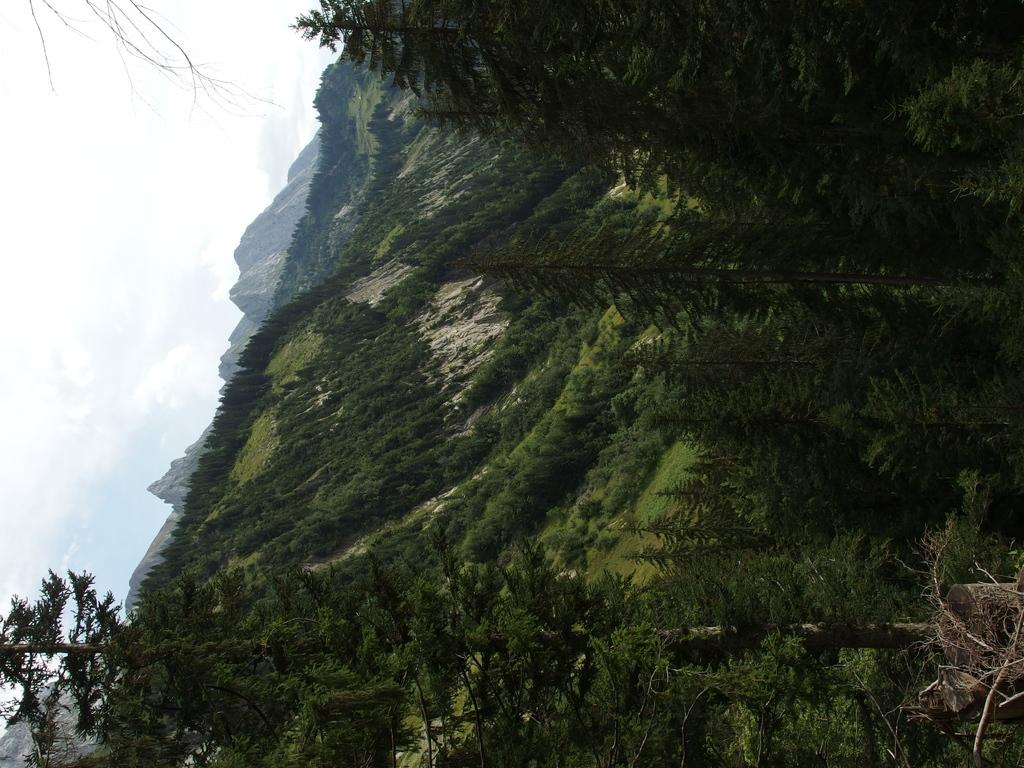What type of natural formation is visible in the image? The image contains mountains. What covers the mountains in the image? The mountains are covered with plants and trees. Can you describe the tree on the left side of the image? There is a tree to the left in the image. What is visible in the sky in the image? There are clouds in the sky. How many cattle can be seen grazing in the image? There are no cattle present in the image. Is there a drain visible in the image? There is no drain present in the image. 